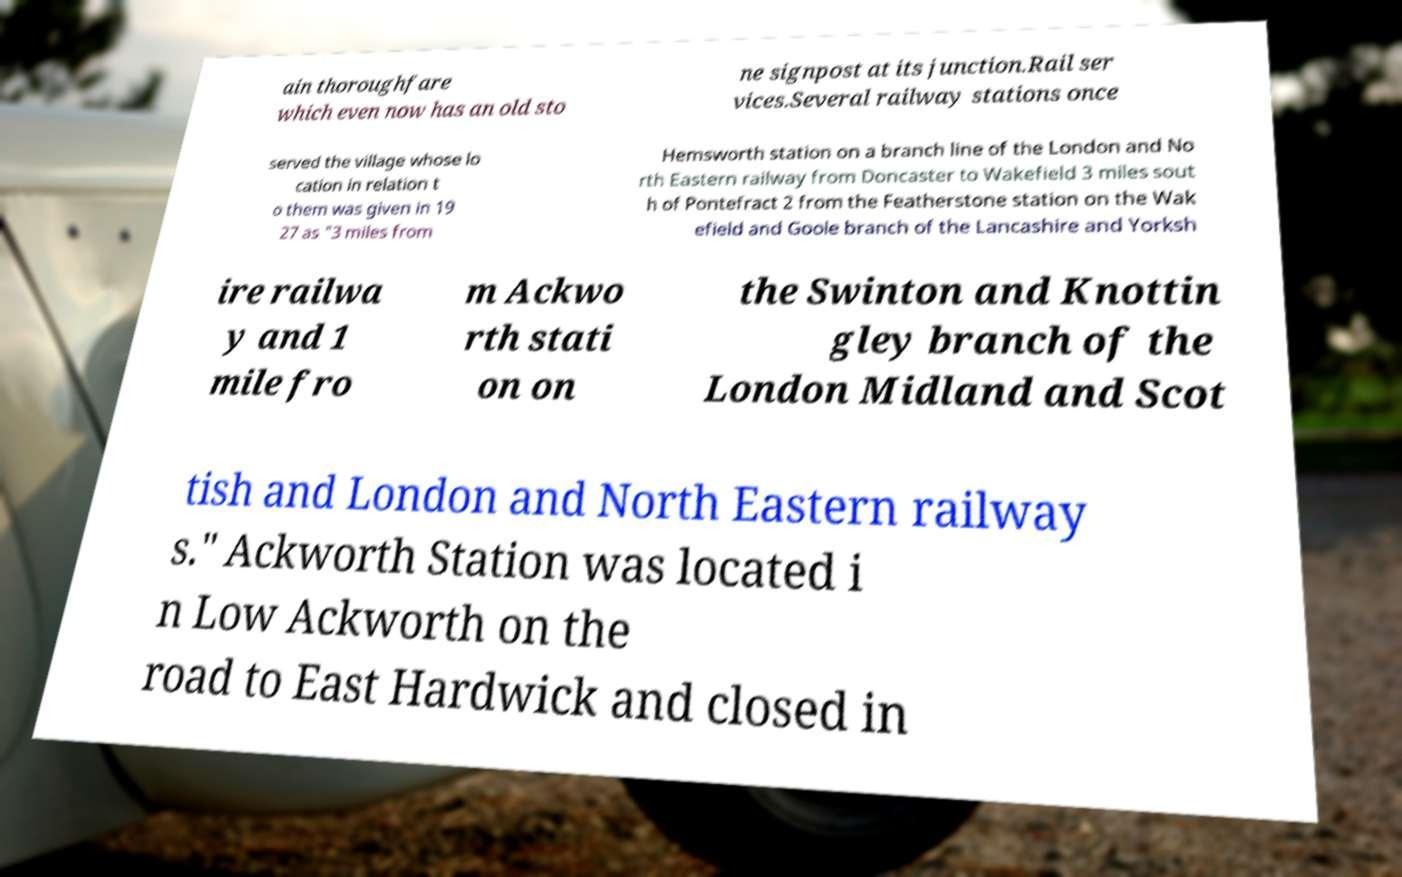I need the written content from this picture converted into text. Can you do that? ain thoroughfare which even now has an old sto ne signpost at its junction.Rail ser vices.Several railway stations once served the village whose lo cation in relation t o them was given in 19 27 as "3 miles from Hemsworth station on a branch line of the London and No rth Eastern railway from Doncaster to Wakefield 3 miles sout h of Pontefract 2 from the Featherstone station on the Wak efield and Goole branch of the Lancashire and Yorksh ire railwa y and 1 mile fro m Ackwo rth stati on on the Swinton and Knottin gley branch of the London Midland and Scot tish and London and North Eastern railway s." Ackworth Station was located i n Low Ackworth on the road to East Hardwick and closed in 